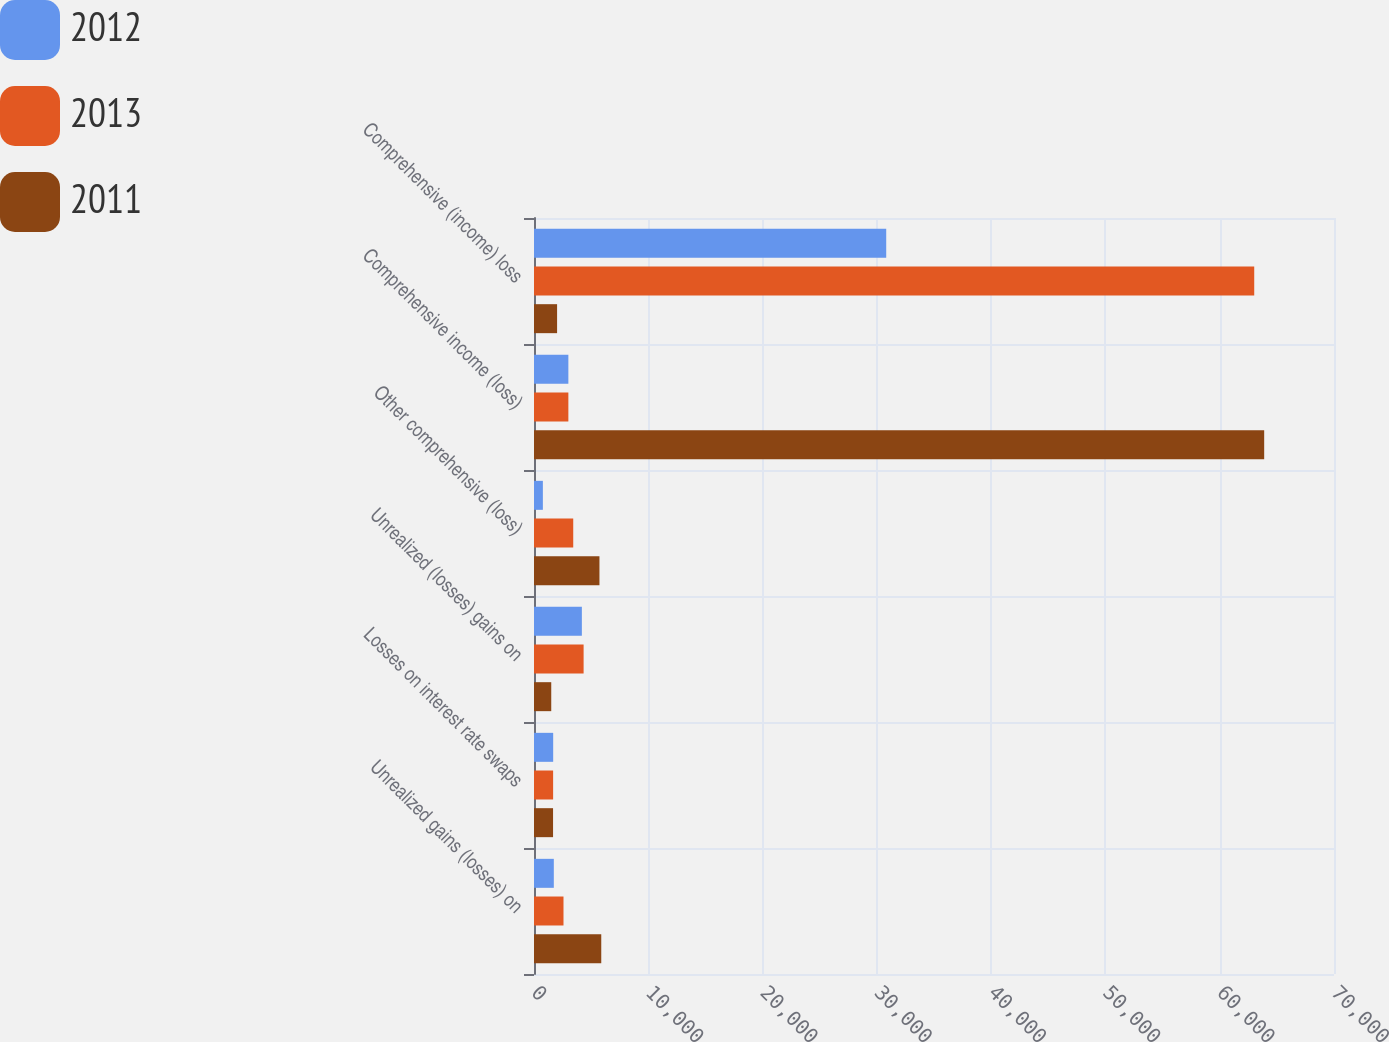Convert chart. <chart><loc_0><loc_0><loc_500><loc_500><stacked_bar_chart><ecel><fcel>Unrealized gains (losses) on<fcel>Losses on interest rate swaps<fcel>Unrealized (losses) gains on<fcel>Other comprehensive (loss)<fcel>Comprehensive income (loss)<fcel>Comprehensive (income) loss<nl><fcel>2012<fcel>1734<fcel>1678<fcel>4188<fcel>776<fcel>3007<fcel>30819<nl><fcel>2013<fcel>2581<fcel>1673<fcel>4341<fcel>3433<fcel>3007<fcel>63020<nl><fcel>2011<fcel>5885<fcel>1667<fcel>1509<fcel>5727<fcel>63891<fcel>2020<nl></chart> 